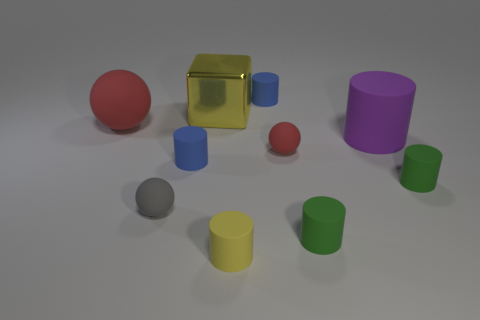Subtract all yellow cylinders. How many cylinders are left? 5 Subtract all large purple cylinders. How many cylinders are left? 5 Subtract all yellow cylinders. Subtract all red spheres. How many cylinders are left? 5 Subtract all balls. How many objects are left? 7 Add 1 large red spheres. How many large red spheres exist? 2 Subtract 1 yellow cubes. How many objects are left? 9 Subtract all small matte things. Subtract all cyan rubber cylinders. How many objects are left? 3 Add 3 red rubber balls. How many red rubber balls are left? 5 